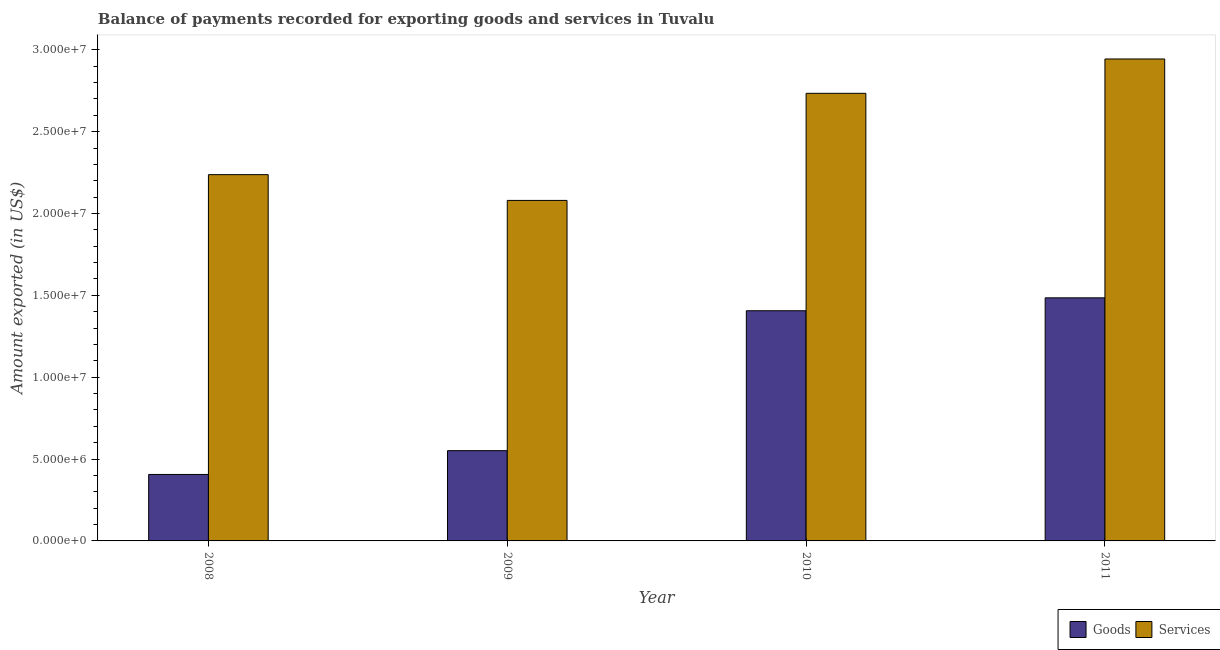How many different coloured bars are there?
Ensure brevity in your answer.  2. Are the number of bars per tick equal to the number of legend labels?
Ensure brevity in your answer.  Yes. Are the number of bars on each tick of the X-axis equal?
Your answer should be very brief. Yes. How many bars are there on the 2nd tick from the left?
Provide a succinct answer. 2. What is the label of the 4th group of bars from the left?
Your response must be concise. 2011. What is the amount of services exported in 2010?
Make the answer very short. 2.73e+07. Across all years, what is the maximum amount of services exported?
Ensure brevity in your answer.  2.94e+07. Across all years, what is the minimum amount of goods exported?
Your answer should be very brief. 4.06e+06. In which year was the amount of services exported maximum?
Ensure brevity in your answer.  2011. What is the total amount of goods exported in the graph?
Your response must be concise. 3.85e+07. What is the difference between the amount of services exported in 2008 and that in 2011?
Provide a succinct answer. -7.07e+06. What is the difference between the amount of goods exported in 2008 and the amount of services exported in 2010?
Your answer should be very brief. -1.00e+07. What is the average amount of goods exported per year?
Offer a very short reply. 9.62e+06. What is the ratio of the amount of services exported in 2008 to that in 2011?
Give a very brief answer. 0.76. Is the difference between the amount of goods exported in 2008 and 2010 greater than the difference between the amount of services exported in 2008 and 2010?
Make the answer very short. No. What is the difference between the highest and the second highest amount of goods exported?
Your answer should be compact. 7.88e+05. What is the difference between the highest and the lowest amount of goods exported?
Ensure brevity in your answer.  1.08e+07. In how many years, is the amount of services exported greater than the average amount of services exported taken over all years?
Offer a very short reply. 2. What does the 1st bar from the left in 2009 represents?
Provide a succinct answer. Goods. What does the 1st bar from the right in 2010 represents?
Provide a succinct answer. Services. How many years are there in the graph?
Give a very brief answer. 4. Are the values on the major ticks of Y-axis written in scientific E-notation?
Give a very brief answer. Yes. Does the graph contain any zero values?
Ensure brevity in your answer.  No. Does the graph contain grids?
Offer a terse response. No. What is the title of the graph?
Provide a short and direct response. Balance of payments recorded for exporting goods and services in Tuvalu. What is the label or title of the Y-axis?
Offer a very short reply. Amount exported (in US$). What is the Amount exported (in US$) in Goods in 2008?
Make the answer very short. 4.06e+06. What is the Amount exported (in US$) in Services in 2008?
Offer a very short reply. 2.24e+07. What is the Amount exported (in US$) of Goods in 2009?
Your answer should be compact. 5.51e+06. What is the Amount exported (in US$) of Services in 2009?
Provide a succinct answer. 2.08e+07. What is the Amount exported (in US$) in Goods in 2010?
Ensure brevity in your answer.  1.41e+07. What is the Amount exported (in US$) of Services in 2010?
Provide a short and direct response. 2.73e+07. What is the Amount exported (in US$) in Goods in 2011?
Your answer should be compact. 1.48e+07. What is the Amount exported (in US$) of Services in 2011?
Provide a short and direct response. 2.94e+07. Across all years, what is the maximum Amount exported (in US$) in Goods?
Your response must be concise. 1.48e+07. Across all years, what is the maximum Amount exported (in US$) in Services?
Your answer should be very brief. 2.94e+07. Across all years, what is the minimum Amount exported (in US$) in Goods?
Keep it short and to the point. 4.06e+06. Across all years, what is the minimum Amount exported (in US$) in Services?
Your response must be concise. 2.08e+07. What is the total Amount exported (in US$) of Goods in the graph?
Your response must be concise. 3.85e+07. What is the total Amount exported (in US$) of Services in the graph?
Make the answer very short. 1.00e+08. What is the difference between the Amount exported (in US$) in Goods in 2008 and that in 2009?
Offer a terse response. -1.45e+06. What is the difference between the Amount exported (in US$) of Services in 2008 and that in 2009?
Offer a very short reply. 1.57e+06. What is the difference between the Amount exported (in US$) of Goods in 2008 and that in 2010?
Your response must be concise. -1.00e+07. What is the difference between the Amount exported (in US$) of Services in 2008 and that in 2010?
Give a very brief answer. -4.97e+06. What is the difference between the Amount exported (in US$) of Goods in 2008 and that in 2011?
Provide a succinct answer. -1.08e+07. What is the difference between the Amount exported (in US$) in Services in 2008 and that in 2011?
Provide a short and direct response. -7.07e+06. What is the difference between the Amount exported (in US$) in Goods in 2009 and that in 2010?
Your response must be concise. -8.55e+06. What is the difference between the Amount exported (in US$) of Services in 2009 and that in 2010?
Your answer should be compact. -6.54e+06. What is the difference between the Amount exported (in US$) in Goods in 2009 and that in 2011?
Your answer should be very brief. -9.34e+06. What is the difference between the Amount exported (in US$) in Services in 2009 and that in 2011?
Your answer should be compact. -8.64e+06. What is the difference between the Amount exported (in US$) in Goods in 2010 and that in 2011?
Give a very brief answer. -7.88e+05. What is the difference between the Amount exported (in US$) in Services in 2010 and that in 2011?
Ensure brevity in your answer.  -2.10e+06. What is the difference between the Amount exported (in US$) in Goods in 2008 and the Amount exported (in US$) in Services in 2009?
Provide a succinct answer. -1.67e+07. What is the difference between the Amount exported (in US$) in Goods in 2008 and the Amount exported (in US$) in Services in 2010?
Give a very brief answer. -2.33e+07. What is the difference between the Amount exported (in US$) in Goods in 2008 and the Amount exported (in US$) in Services in 2011?
Keep it short and to the point. -2.54e+07. What is the difference between the Amount exported (in US$) of Goods in 2009 and the Amount exported (in US$) of Services in 2010?
Offer a very short reply. -2.18e+07. What is the difference between the Amount exported (in US$) of Goods in 2009 and the Amount exported (in US$) of Services in 2011?
Your answer should be very brief. -2.39e+07. What is the difference between the Amount exported (in US$) in Goods in 2010 and the Amount exported (in US$) in Services in 2011?
Give a very brief answer. -1.54e+07. What is the average Amount exported (in US$) in Goods per year?
Keep it short and to the point. 9.62e+06. What is the average Amount exported (in US$) of Services per year?
Keep it short and to the point. 2.50e+07. In the year 2008, what is the difference between the Amount exported (in US$) of Goods and Amount exported (in US$) of Services?
Keep it short and to the point. -1.83e+07. In the year 2009, what is the difference between the Amount exported (in US$) in Goods and Amount exported (in US$) in Services?
Your answer should be very brief. -1.53e+07. In the year 2010, what is the difference between the Amount exported (in US$) of Goods and Amount exported (in US$) of Services?
Your answer should be very brief. -1.33e+07. In the year 2011, what is the difference between the Amount exported (in US$) of Goods and Amount exported (in US$) of Services?
Provide a short and direct response. -1.46e+07. What is the ratio of the Amount exported (in US$) in Goods in 2008 to that in 2009?
Ensure brevity in your answer.  0.74. What is the ratio of the Amount exported (in US$) of Services in 2008 to that in 2009?
Give a very brief answer. 1.08. What is the ratio of the Amount exported (in US$) in Goods in 2008 to that in 2010?
Provide a short and direct response. 0.29. What is the ratio of the Amount exported (in US$) of Services in 2008 to that in 2010?
Keep it short and to the point. 0.82. What is the ratio of the Amount exported (in US$) in Goods in 2008 to that in 2011?
Offer a terse response. 0.27. What is the ratio of the Amount exported (in US$) in Services in 2008 to that in 2011?
Make the answer very short. 0.76. What is the ratio of the Amount exported (in US$) in Goods in 2009 to that in 2010?
Your answer should be compact. 0.39. What is the ratio of the Amount exported (in US$) in Services in 2009 to that in 2010?
Give a very brief answer. 0.76. What is the ratio of the Amount exported (in US$) of Goods in 2009 to that in 2011?
Ensure brevity in your answer.  0.37. What is the ratio of the Amount exported (in US$) in Services in 2009 to that in 2011?
Give a very brief answer. 0.71. What is the ratio of the Amount exported (in US$) of Goods in 2010 to that in 2011?
Ensure brevity in your answer.  0.95. What is the ratio of the Amount exported (in US$) of Services in 2010 to that in 2011?
Offer a very short reply. 0.93. What is the difference between the highest and the second highest Amount exported (in US$) in Goods?
Your answer should be compact. 7.88e+05. What is the difference between the highest and the second highest Amount exported (in US$) of Services?
Offer a terse response. 2.10e+06. What is the difference between the highest and the lowest Amount exported (in US$) in Goods?
Offer a very short reply. 1.08e+07. What is the difference between the highest and the lowest Amount exported (in US$) of Services?
Ensure brevity in your answer.  8.64e+06. 